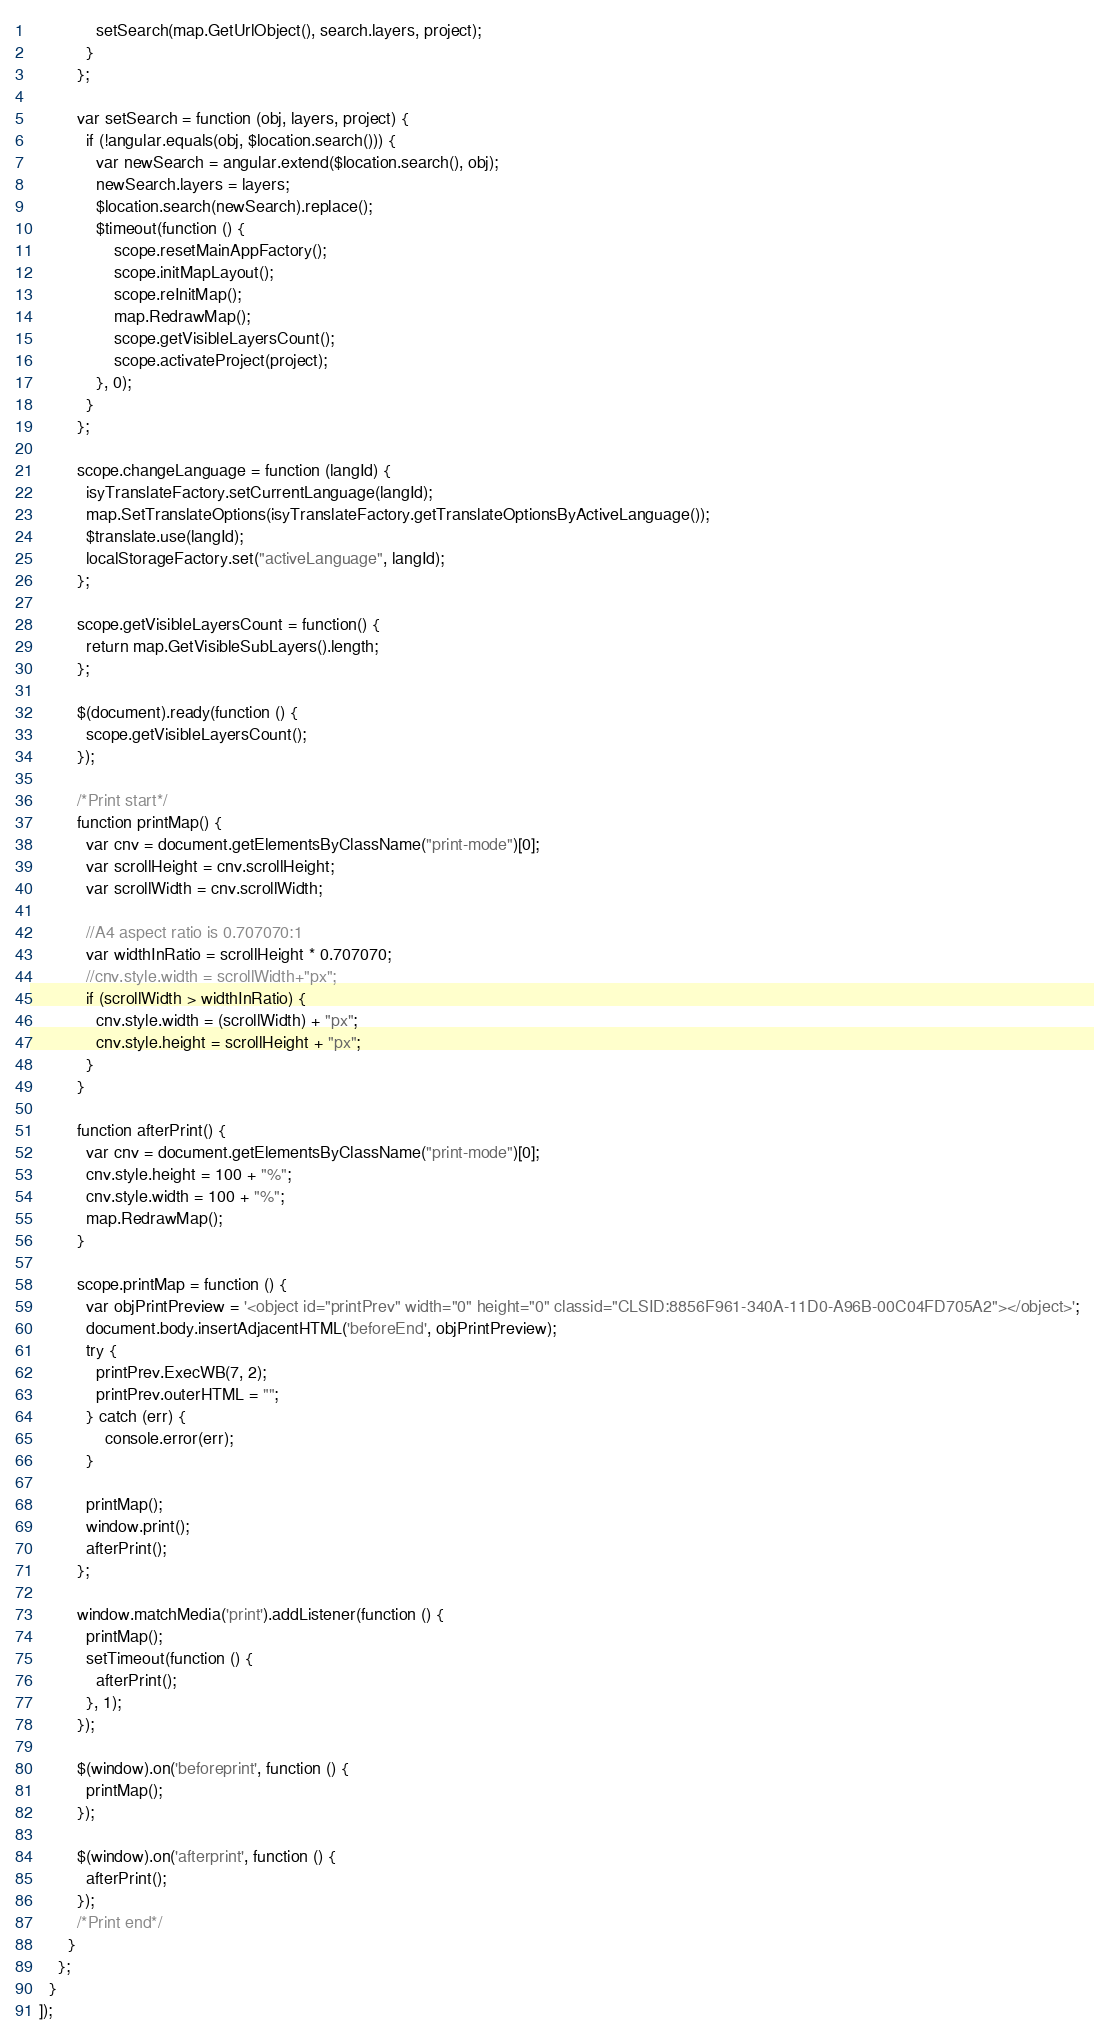Convert code to text. <code><loc_0><loc_0><loc_500><loc_500><_JavaScript_>              setSearch(map.GetUrlObject(), search.layers, project);
            }
          };

          var setSearch = function (obj, layers, project) {
            if (!angular.equals(obj, $location.search())) {
              var newSearch = angular.extend($location.search(), obj);
              newSearch.layers = layers;
              $location.search(newSearch).replace();
              $timeout(function () {
                  scope.resetMainAppFactory();
                  scope.initMapLayout();
                  scope.reInitMap();
                  map.RedrawMap();
                  scope.getVisibleLayersCount();
                  scope.activateProject(project);
              }, 0);
            }
          };

          scope.changeLanguage = function (langId) {
            isyTranslateFactory.setCurrentLanguage(langId);
            map.SetTranslateOptions(isyTranslateFactory.getTranslateOptionsByActiveLanguage());
            $translate.use(langId);
            localStorageFactory.set("activeLanguage", langId);
          };

          scope.getVisibleLayersCount = function() {
            return map.GetVisibleSubLayers().length;
          };

          $(document).ready(function () {
            scope.getVisibleLayersCount();
          });

          /*Print start*/
          function printMap() {
            var cnv = document.getElementsByClassName("print-mode")[0];
            var scrollHeight = cnv.scrollHeight;
            var scrollWidth = cnv.scrollWidth;

            //A4 aspect ratio is 0.707070:1
            var widthInRatio = scrollHeight * 0.707070;
            //cnv.style.width = scrollWidth+"px";
            if (scrollWidth > widthInRatio) {
              cnv.style.width = (scrollWidth) + "px";
              cnv.style.height = scrollHeight + "px";
            }
          }

          function afterPrint() {
            var cnv = document.getElementsByClassName("print-mode")[0];
            cnv.style.height = 100 + "%";
            cnv.style.width = 100 + "%";
            map.RedrawMap();
          }

          scope.printMap = function () {
            var objPrintPreview = '<object id="printPrev" width="0" height="0" classid="CLSID:8856F961-340A-11D0-A96B-00C04FD705A2"></object>';
            document.body.insertAdjacentHTML('beforeEnd', objPrintPreview);
            try {
              printPrev.ExecWB(7, 2);
              printPrev.outerHTML = "";
            } catch (err) {
                console.error(err);
            }

            printMap();
            window.print();
            afterPrint();
          };

          window.matchMedia('print').addListener(function () {
            printMap();
            setTimeout(function () {
              afterPrint();
            }, 1);
          });

          $(window).on('beforeprint', function () {
            printMap();
          });

          $(window).on('afterprint', function () {
            afterPrint();
          });
          /*Print end*/
        }
      };
    }
  ]);
</code> 